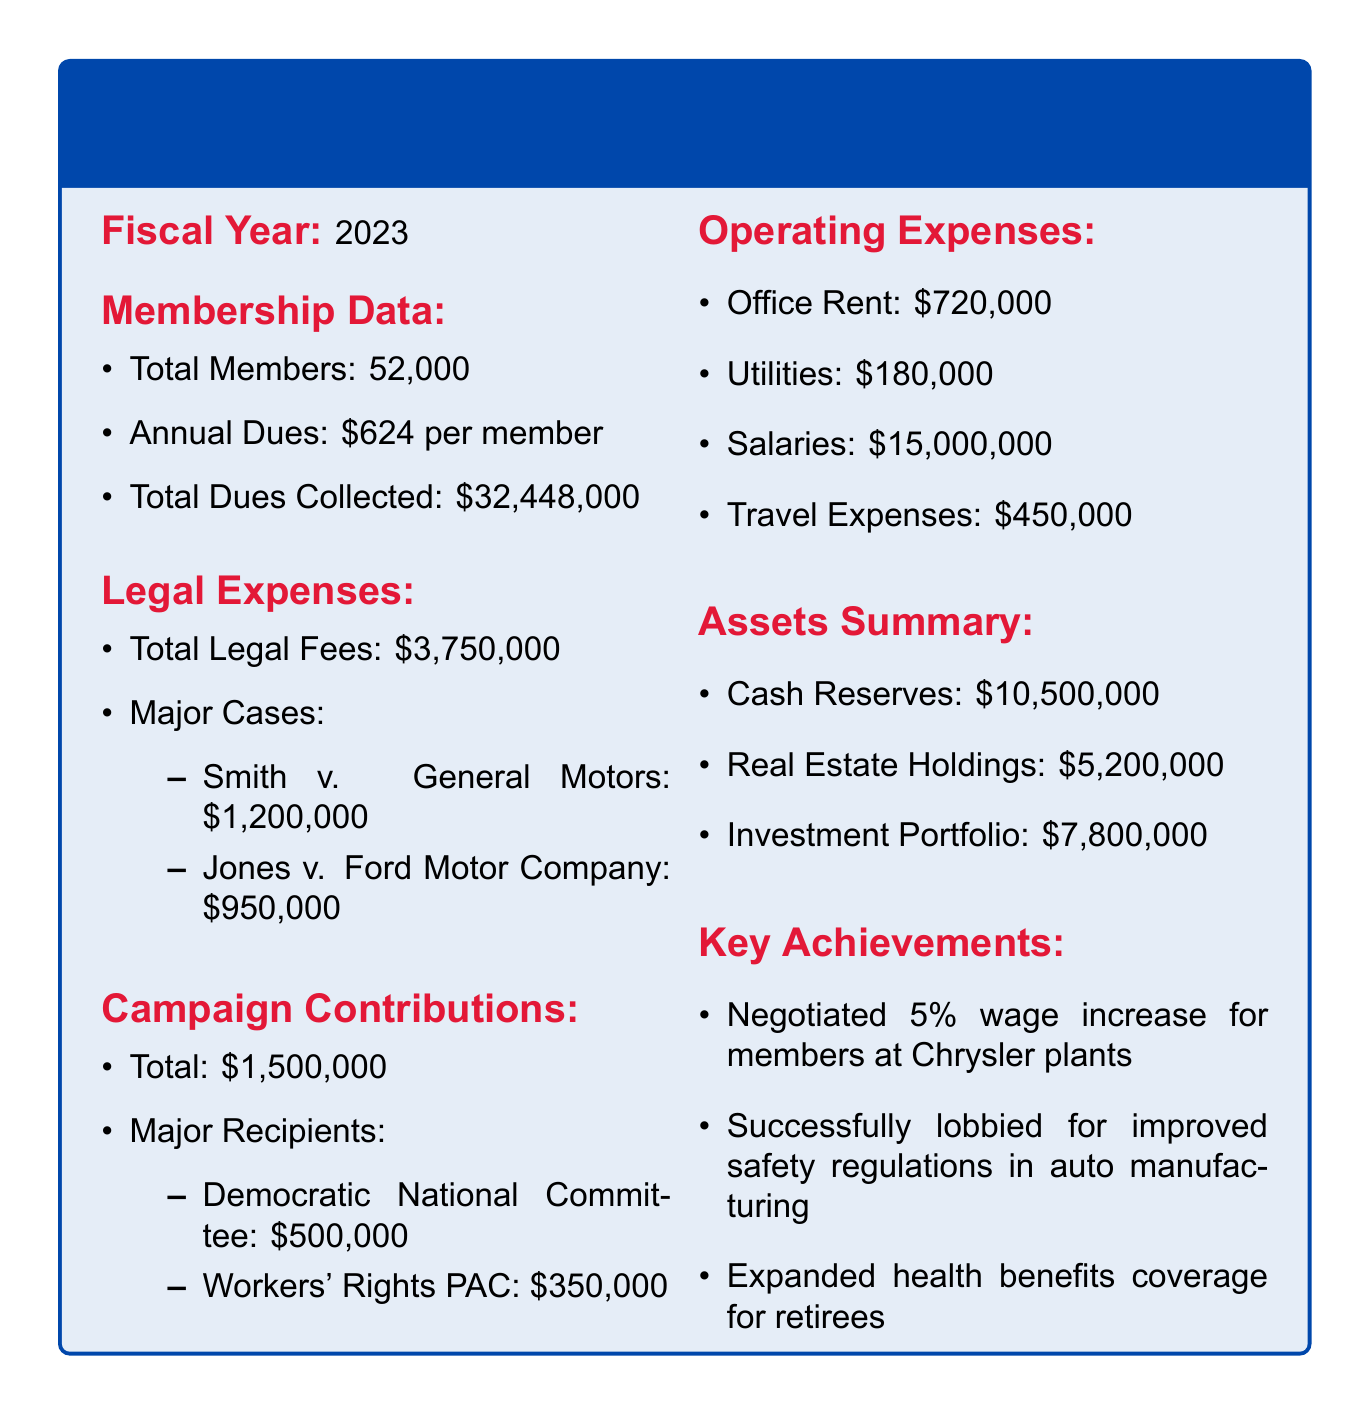What is the total number of members? The total number of members is specifically mentioned in the membership data section of the document.
Answer: 52,000 What are the annual dues per member? The document specifies the amount of annual dues that each member is required to pay.
Answer: $624 per member What is the total amount of legal expenses? The total legal fees are provided in the legal expenses section, encompassing all legal costs incurred.
Answer: $3,750,000 Which case had the highest legal cost? The document lists major cases along with their respective costs, allowing identification of the most expensive case.
Answer: Smith v. General Motors What is the total amount of campaign contributions? The total contributions made towards campaigns are summed up in the campaign contributions section.
Answer: $1,500,000 Which organization received the highest campaign contribution? The major recipients of campaign contributions are listed, making it possible to determine the top recipient.
Answer: Democratic National Committee What are the total operating expenses for salaries? The document outlines various operating expenses, including specific allocations for salaries.
Answer: $15,000,000 What is the total amount in cash reserves? The assets summary provides distinct figures for the financial assets of the labor union, including cash reserves.
Answer: $10,500,000 Which achievement involved wage negotiations? The key achievements section details various successes; one involves wage negotiations specific to members.
Answer: Negotiated 5% wage increase for members at Chrysler plants 